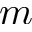Convert formula to latex. <formula><loc_0><loc_0><loc_500><loc_500>m</formula> 